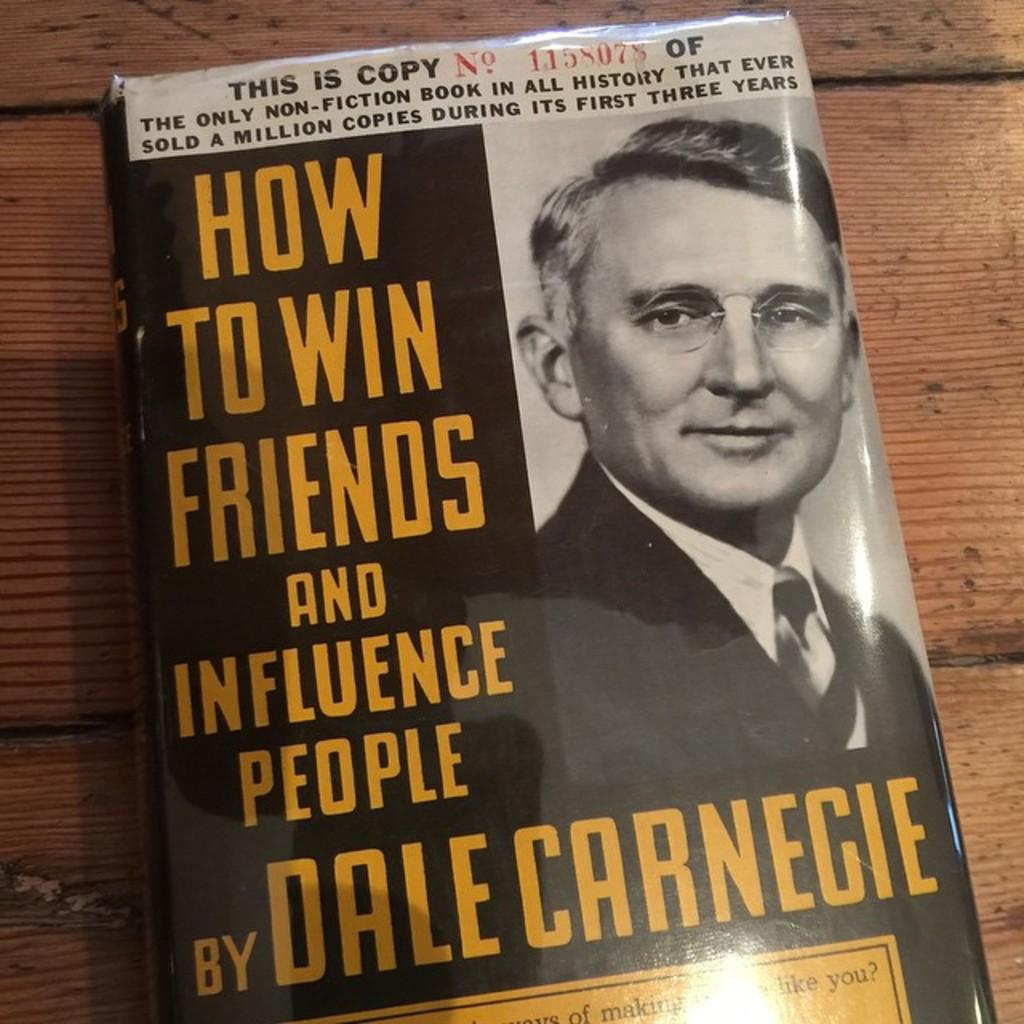What is present in the image related to reading material? There is a book in the image. Where is the book located? The book is on a wooden surface. What can be seen on the cover page of the book? There is an image and matter written on the cover page of the book. What type of noise can be heard coming from the book in the image? There is no noise coming from the book in the image, as books are not capable of producing sound. 